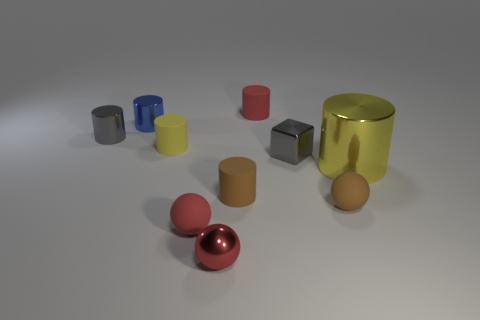Assuming these objects have different weights, which one do you think would be the heaviest and why? Assuming the objects are made from materials their appearances suggest, the heaviest object is likely the large golden cylinder on the right, due to its size and the fact that it appears to be metallic. Metals typically have greater densities than materials like plastic or ceramics, so a large metallic object like this one would be expected to weigh more than the others in the collection. 